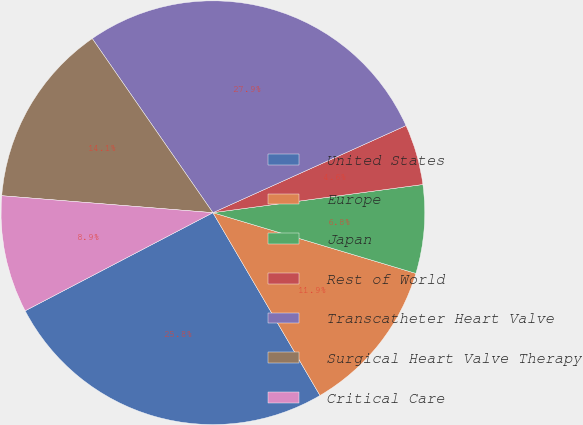<chart> <loc_0><loc_0><loc_500><loc_500><pie_chart><fcel>United States<fcel>Europe<fcel>Japan<fcel>Rest of World<fcel>Transcatheter Heart Valve<fcel>Surgical Heart Valve Therapy<fcel>Critical Care<nl><fcel>25.77%<fcel>11.94%<fcel>6.75%<fcel>4.62%<fcel>27.9%<fcel>14.08%<fcel>8.94%<nl></chart> 